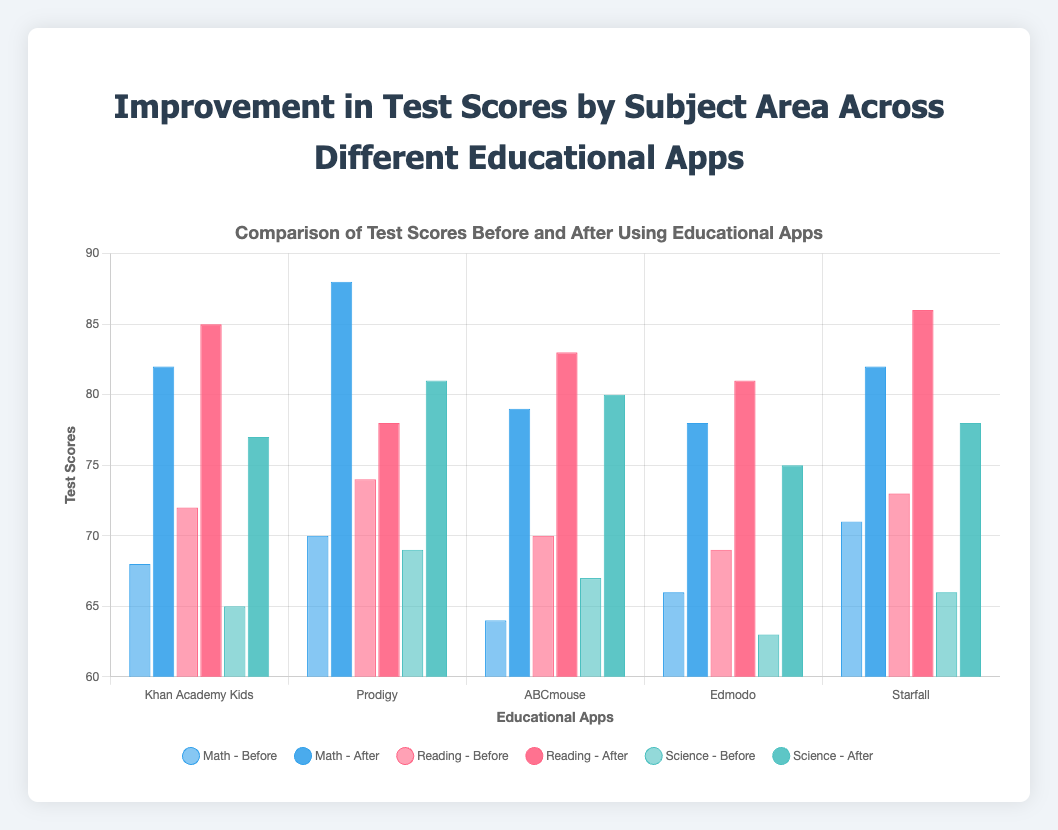Which app shows the greatest improvement in Math scores? To determine the app with the greatest improvement in Math scores, look at the difference between the before and after test scores for Math for each app. The improvements are: Khan Academy Kids (82-68=14), Prodigy (88-70=18), ABCmouse (79-64=15), Edmodo (78-66=12), Starfall (82-71=11). The greatest improvement is observed in Prodigy.
Answer: Prodigy Which app has the smallest improvement in Reading scores? To find the app with the smallest improvement in Reading scores, look at the difference between the before and after test scores for Reading for each app. The improvements are: Khan Academy Kids (85-72=13), Prodigy (78-74=4), ABCmouse (83-70=13), Edmodo (81-69=12), Starfall (86-73=13). The smallest improvement is observed in Prodigy.
Answer: Prodigy What is the total improvement for ABCmouse across all subjects? Calculate the total improvement for ABCmouse by summing the differences between the before and after test scores for all three subjects (Math, Reading, Science). The differences are: Math (79-64=15), Reading (83-70=13), Science (80-67=13). The total improvement is 15 + 13 + 13 = 41.
Answer: 41 Which subject had the highest final score using Starfall? Compare the after test scores of Starfall for each subject: Math (82), Reading (86), Science (78). The highest final score is in Reading.
Answer: Reading How does the improvement in Reading for Khan Academy Kids compare to the improvement in Science for Edmodo? Calculate the differences between the before and after test scores for Reading for Khan Academy Kids and Science for Edmodo. The improvements are: Khan Academy Kids Reading (85-72=13), Edmodo Science (75-63=12). Khan Academy Kids' improvement in Reading is 1 point higher than Edmodo's improvement in Science.
Answer: 1 point higher What is the average after test score for all subjects in Edmodo? Calculate the average after test scores by summing the after test scores for all subjects in Edmodo and dividing by the number of subjects. The scores are: Math (78), Reading (81), Science (75). The average is (78 + 81 + 75) / 3 = 234 / 3 = 78.
Answer: 78 